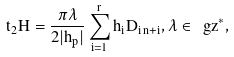<formula> <loc_0><loc_0><loc_500><loc_500>t _ { 2 } H = \frac { \pi \lambda } { 2 | h _ { p } | } \sum _ { i = 1 } ^ { r } h _ { i } D _ { i \, n + i } , \lambda \in \ g z ^ { * } ,</formula> 